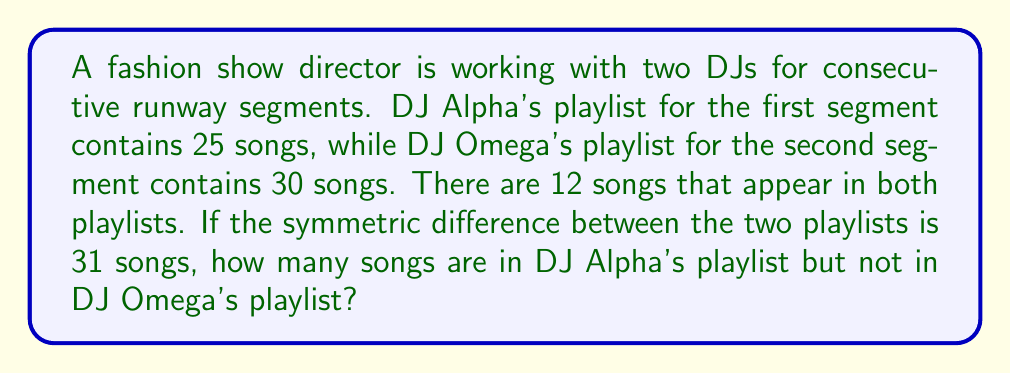Could you help me with this problem? Let's approach this step-by-step using set theory:

1) Let A be the set of songs in DJ Alpha's playlist and O be the set of songs in DJ Omega's playlist.

2) We're given:
   $|A| = 25$ (Alpha's playlist has 25 songs)
   $|O| = 30$ (Omega's playlist has 30 songs)
   $|A \cap O| = 12$ (12 songs are in both playlists)
   $|A \triangle O| = 31$ (the symmetric difference is 31 songs)

3) The symmetric difference is defined as:
   $A \triangle O = (A \setminus O) \cup (O \setminus A)$

4) We can express this in terms of cardinalities:
   $|A \triangle O| = |A \setminus O| + |O \setminus A|$

5) We're asked to find $|A \setminus O|$, which is the number of songs in Alpha's playlist but not in Omega's.

6) We can use the formula:
   $|A \setminus O| = |A| - |A \cap O|$
   $|O \setminus A| = |O| - |A \cap O|$

7) Substituting into the symmetric difference equation:
   $31 = (25 - 12) + (30 - 12)$
   $31 = 13 + 18$
   $31 = 31$

8) Therefore, $|A \setminus O| = 25 - 12 = 13$
Answer: 13 songs 